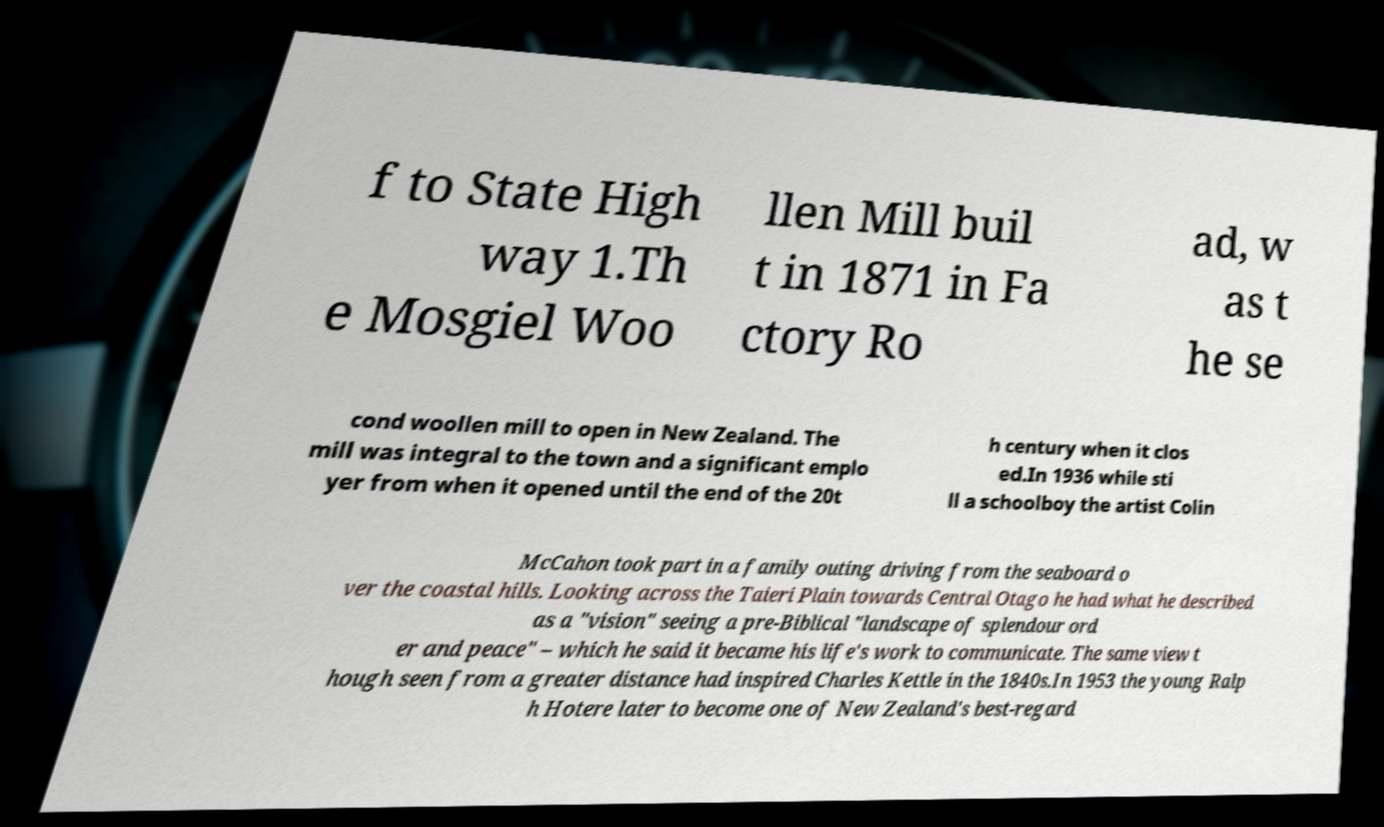I need the written content from this picture converted into text. Can you do that? f to State High way 1.Th e Mosgiel Woo llen Mill buil t in 1871 in Fa ctory Ro ad, w as t he se cond woollen mill to open in New Zealand. The mill was integral to the town and a significant emplo yer from when it opened until the end of the 20t h century when it clos ed.In 1936 while sti ll a schoolboy the artist Colin McCahon took part in a family outing driving from the seaboard o ver the coastal hills. Looking across the Taieri Plain towards Central Otago he had what he described as a "vision" seeing a pre-Biblical "landscape of splendour ord er and peace" – which he said it became his life's work to communicate. The same view t hough seen from a greater distance had inspired Charles Kettle in the 1840s.In 1953 the young Ralp h Hotere later to become one of New Zealand's best-regard 